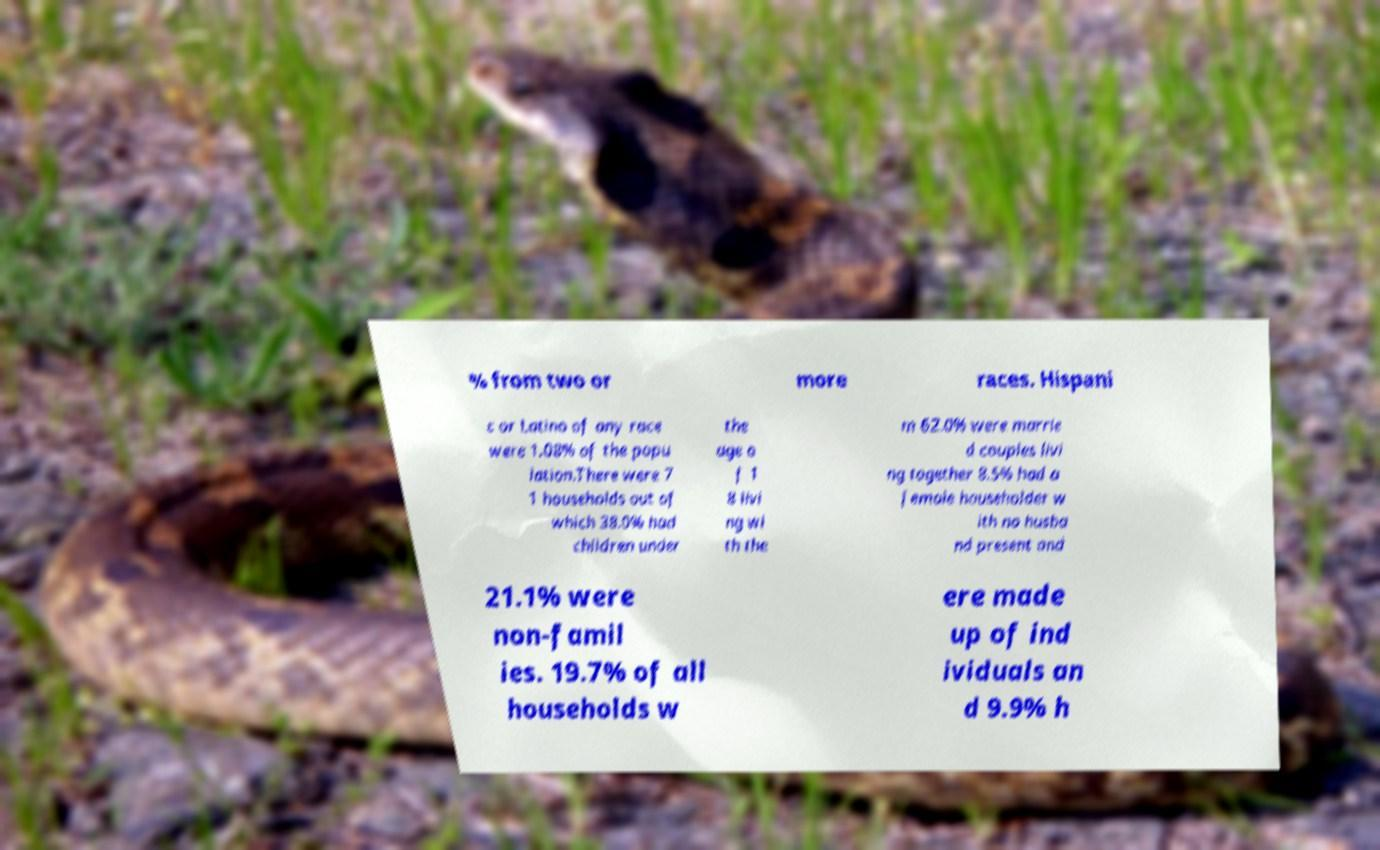There's text embedded in this image that I need extracted. Can you transcribe it verbatim? % from two or more races. Hispani c or Latino of any race were 1.08% of the popu lation.There were 7 1 households out of which 38.0% had children under the age o f 1 8 livi ng wi th the m 62.0% were marrie d couples livi ng together 8.5% had a female householder w ith no husba nd present and 21.1% were non-famil ies. 19.7% of all households w ere made up of ind ividuals an d 9.9% h 